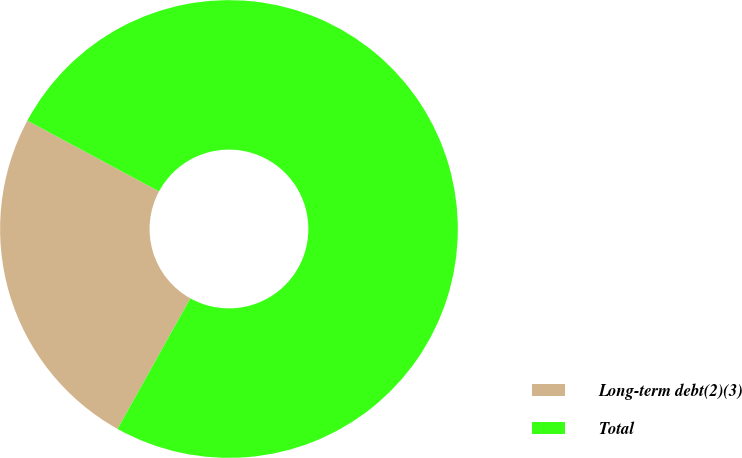Convert chart. <chart><loc_0><loc_0><loc_500><loc_500><pie_chart><fcel>Long-term debt(2)(3)<fcel>Total<nl><fcel>24.76%<fcel>75.24%<nl></chart> 